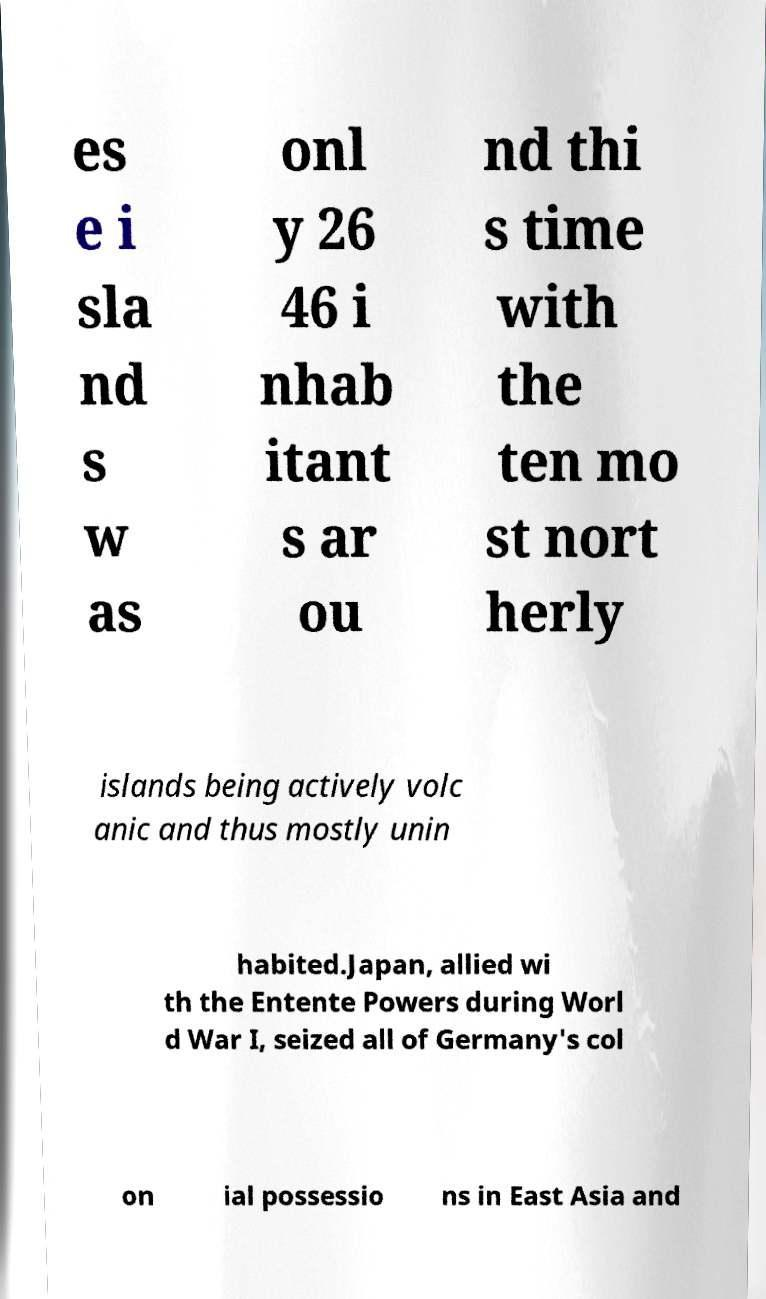Can you read and provide the text displayed in the image?This photo seems to have some interesting text. Can you extract and type it out for me? es e i sla nd s w as onl y 26 46 i nhab itant s ar ou nd thi s time with the ten mo st nort herly islands being actively volc anic and thus mostly unin habited.Japan, allied wi th the Entente Powers during Worl d War I, seized all of Germany's col on ial possessio ns in East Asia and 